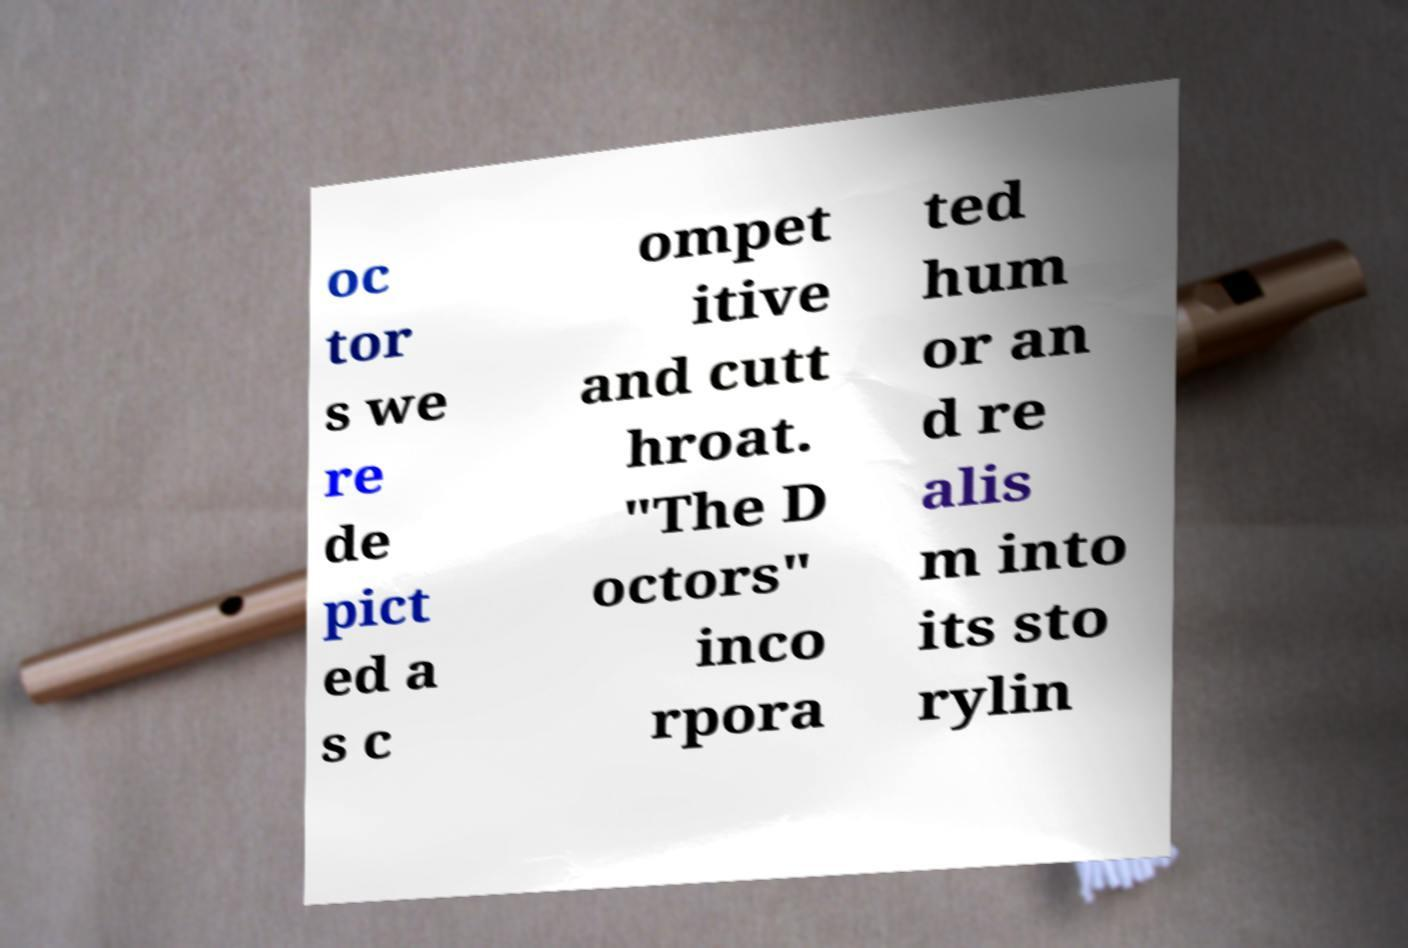For documentation purposes, I need the text within this image transcribed. Could you provide that? oc tor s we re de pict ed a s c ompet itive and cutt hroat. "The D octors" inco rpora ted hum or an d re alis m into its sto rylin 